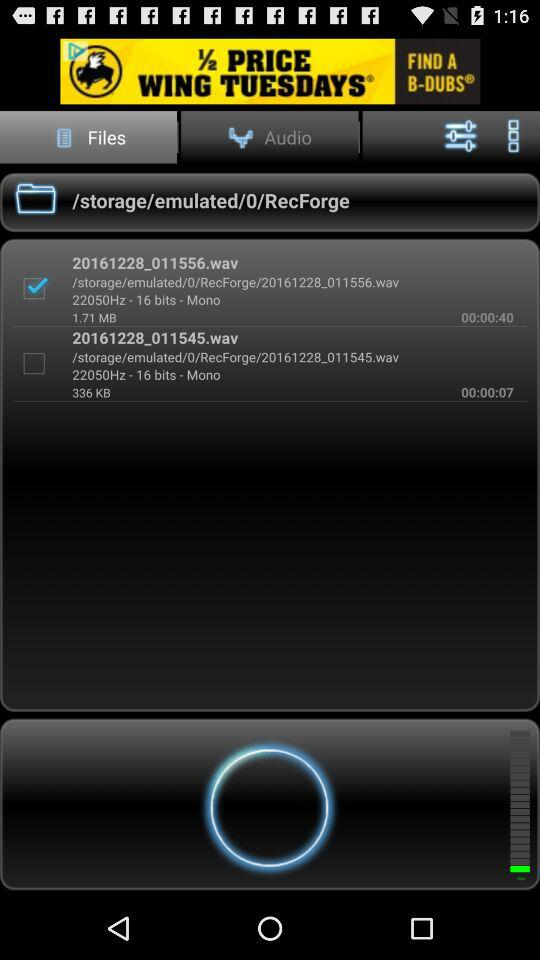How many files are in the folder?
Answer the question using a single word or phrase. 2 